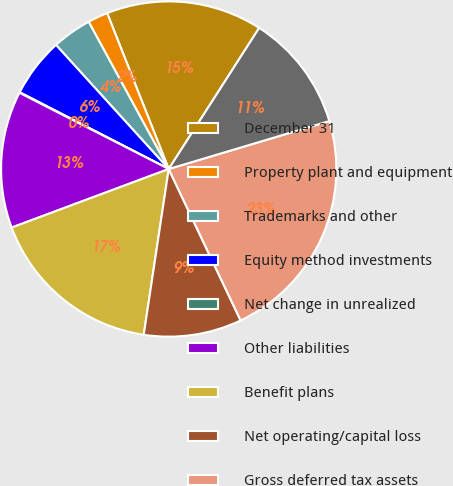Convert chart. <chart><loc_0><loc_0><loc_500><loc_500><pie_chart><fcel>December 31<fcel>Property plant and equipment<fcel>Trademarks and other<fcel>Equity method investments<fcel>Net change in unrealized<fcel>Other liabilities<fcel>Benefit plans<fcel>Net operating/capital loss<fcel>Gross deferred tax assets<fcel>Valuation allowances<nl><fcel>15.06%<fcel>1.94%<fcel>3.81%<fcel>5.69%<fcel>0.06%<fcel>13.19%<fcel>16.94%<fcel>9.44%<fcel>22.56%<fcel>11.31%<nl></chart> 